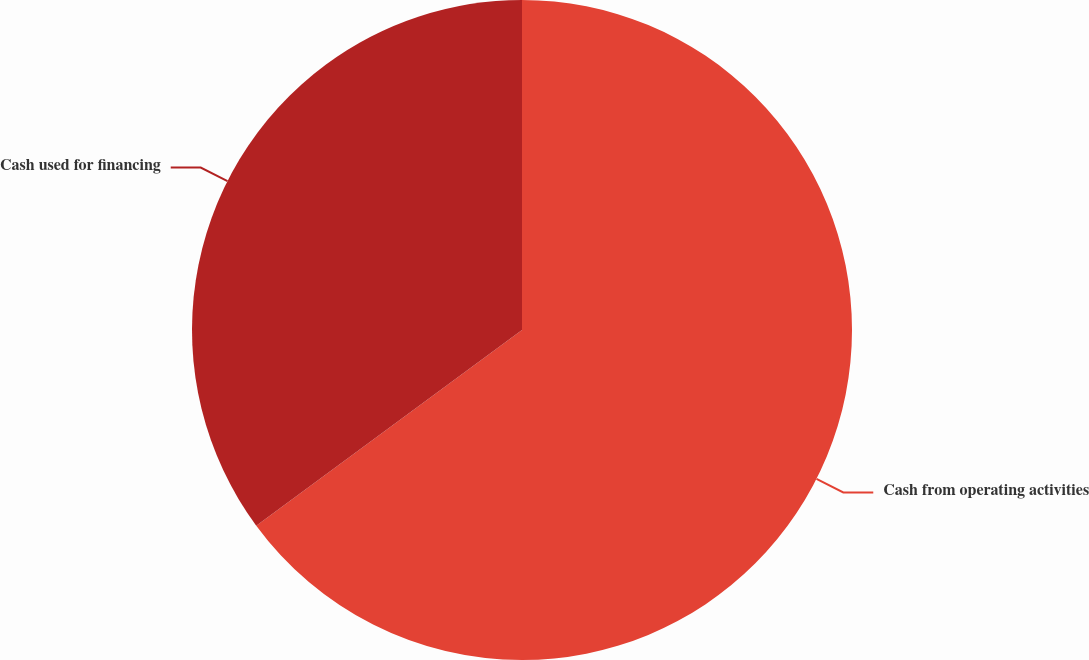<chart> <loc_0><loc_0><loc_500><loc_500><pie_chart><fcel>Cash from operating activities<fcel>Cash used for financing<nl><fcel>64.9%<fcel>35.1%<nl></chart> 